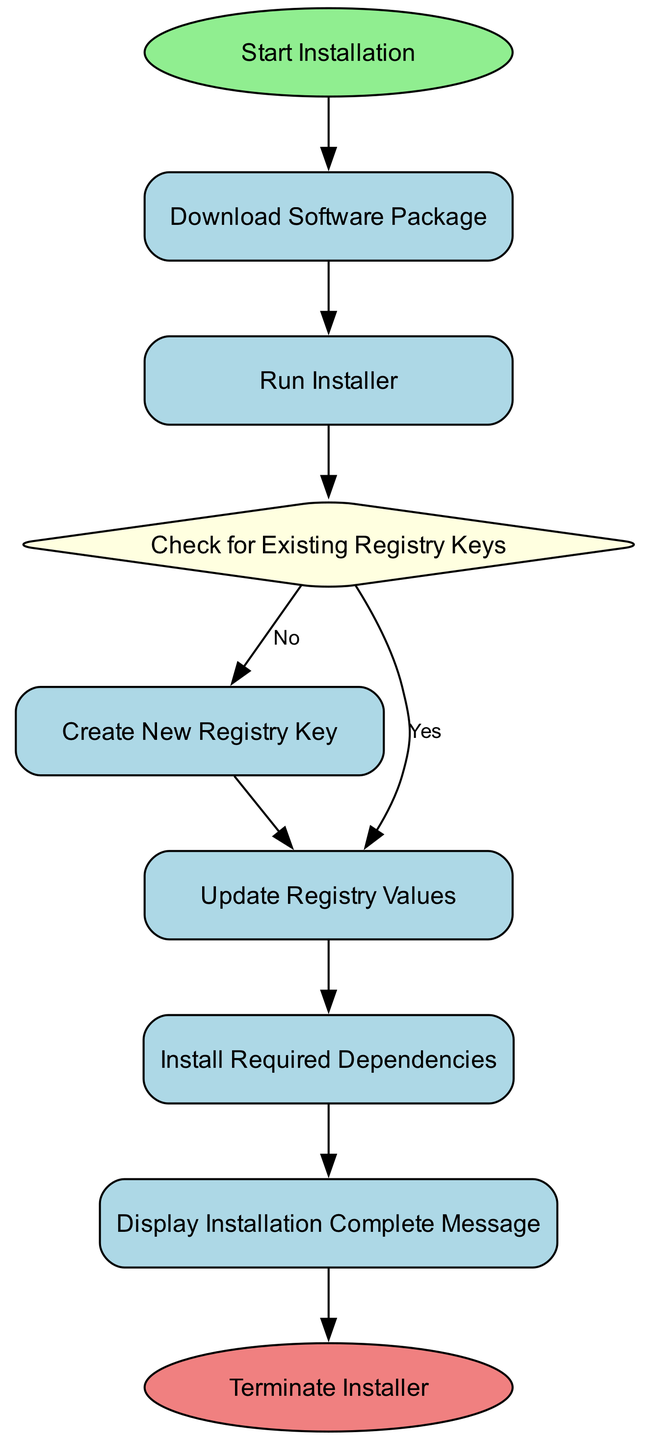What is the first step in the installation process? The first step is indicated by the "Start Installation" node, which is the initial action taken in the flow chart.
Answer: Start Installation How many process nodes are there in the diagram? By counting the nodes labeled as "Process," we identify five of them: "Download Software Package," "Run Installer," "Create New Registry Key," "Update Registry Values," and "Install Required Dependencies."
Answer: Five What happens if there are existing registry keys? If existing registry keys are found, the flow follows the "Yes" path from the "Check for Existing Registry Keys" decision node, leading to the "Update Registry Values" process.
Answer: Update Registry Values What is the last action taken in the installation flow? The last action in the flow is represented by the "Terminate Installer" node, which signifies the completion of the installation process.
Answer: Terminate Installer Which node leads to the installation of required dependencies? The "Update Registry Values" node leads to the "Install Required Dependencies" node, making it the direct precursor for this step.
Answer: Update Registry Values If no existing registry keys are found, what follows next? If no existing registry keys are detected, the flow moves from the "Check for Existing Registry Keys" node to create a "New Registry Key," which is the subsequent action taken in this case.
Answer: Create New Registry Key How many decision nodes are present in the flow chart? There is one decision node in the flow chart, which is the "Check for Existing Registry Keys." This node determines the path of the flow based on conditions.
Answer: One What message is displayed after the installation is complete? The flow chart specifies that after all necessary installation steps, the "Display Installation Complete Message" node is activated to notify the user of completion.
Answer: Display Installation Complete Message 